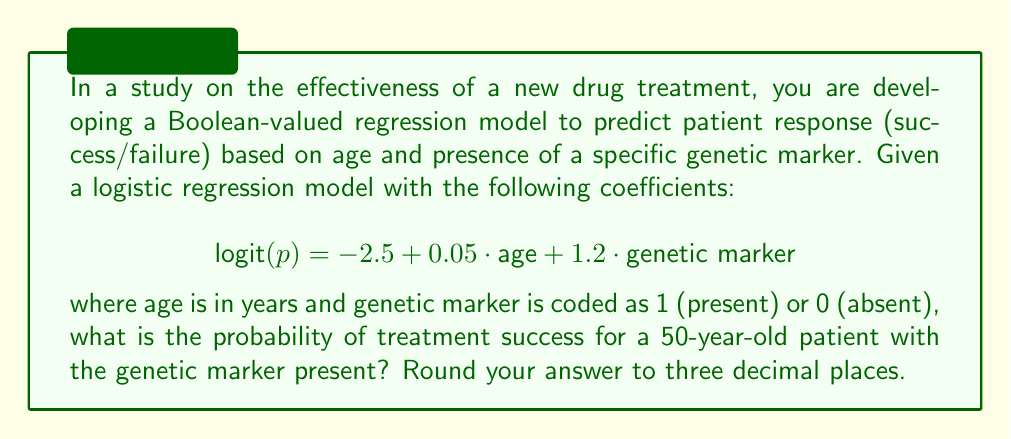What is the answer to this math problem? To solve this problem, we'll follow these steps:

1) The logistic regression model is given in the form of the logit function:

   $$ \text{logit}(p) = \ln(\frac{p}{1-p}) = -2.5 + 0.05 \cdot \text{age} + 1.2 \cdot \text{genetic marker} $$

2) We need to calculate the logit for a 50-year-old patient with the genetic marker present:

   $$ \text{logit}(p) = -2.5 + 0.05 \cdot 50 + 1.2 \cdot 1 $$
   $$ = -2.5 + 2.5 + 1.2 = 1.2 $$

3) Now we have:

   $$ \ln(\frac{p}{1-p}) = 1.2 $$

4) To find p, we need to apply the inverse logit function (also known as the sigmoid function):

   $$ p = \frac{1}{1 + e^{-\text{logit}(p)}} = \frac{1}{1 + e^{-1.2}} $$

5) Calculate this value:

   $$ p = \frac{1}{1 + e^{-1.2}} \approx 0.7685 $$

6) Rounding to three decimal places:

   $$ p \approx 0.769 $$
Answer: 0.769 